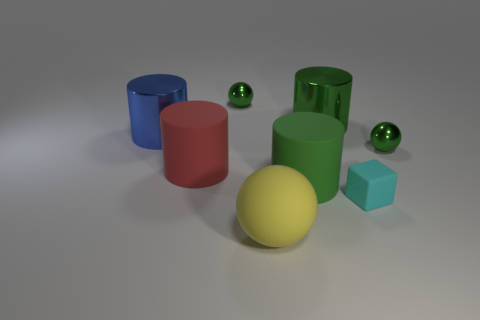The other metal object that is the same size as the blue object is what shape?
Give a very brief answer. Cylinder. Is the material of the tiny green sphere that is left of the cyan matte block the same as the small sphere that is right of the yellow thing?
Your answer should be very brief. Yes. What material is the tiny cyan block that is to the right of the big object in front of the small matte cube made of?
Your response must be concise. Rubber. What size is the green sphere that is behind the large green cylinder behind the small object on the right side of the cyan rubber cube?
Your response must be concise. Small. Is the size of the red rubber cylinder the same as the yellow ball?
Offer a very short reply. Yes. There is a tiny thing that is behind the big blue shiny thing; does it have the same shape as the rubber thing that is in front of the cyan rubber cube?
Provide a succinct answer. Yes. Are there any big matte things on the right side of the large red cylinder that is behind the big green matte cylinder?
Offer a terse response. Yes. Is there a cyan matte ball?
Your answer should be very brief. No. What number of yellow things have the same size as the blue metal thing?
Keep it short and to the point. 1. How many things are both in front of the big green matte object and right of the big yellow sphere?
Your response must be concise. 1. 